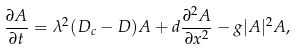Convert formula to latex. <formula><loc_0><loc_0><loc_500><loc_500>\frac { \partial A } { \partial t } = \lambda ^ { 2 } ( D _ { c } - D ) A + d \frac { \partial ^ { 2 } A } { \partial x ^ { 2 } } - g | A | ^ { 2 } A ,</formula> 